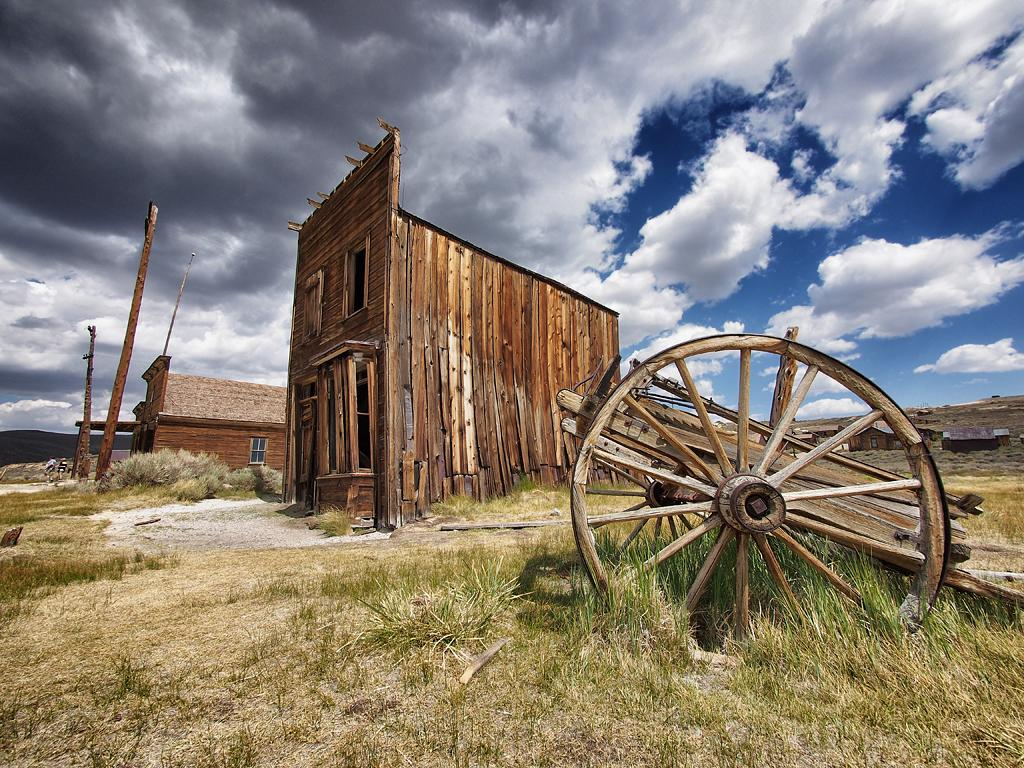What type of vegetation is present in the image? There is grass in the image. What type of vehicle can be seen in the image? There is a wooden coach in the image. What type of structures are visible in the background of the image? There are wooden houses in the background of the image. What can be seen in the sky in the background of the image? There are clouds in the sky in the background of the image. Can you see any wounds on the wooden coach in the image? There are no wounds visible on the wooden coach in the image, as it is a static object and not a living being. 